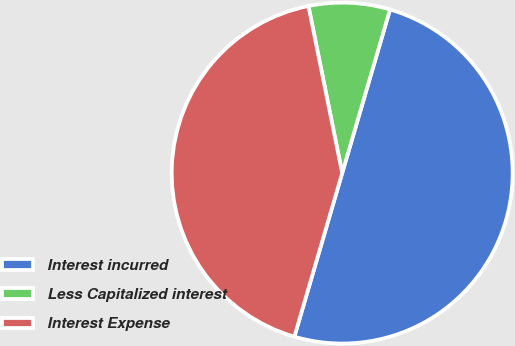Convert chart. <chart><loc_0><loc_0><loc_500><loc_500><pie_chart><fcel>Interest incurred<fcel>Less Capitalized interest<fcel>Interest Expense<nl><fcel>50.0%<fcel>7.7%<fcel>42.3%<nl></chart> 